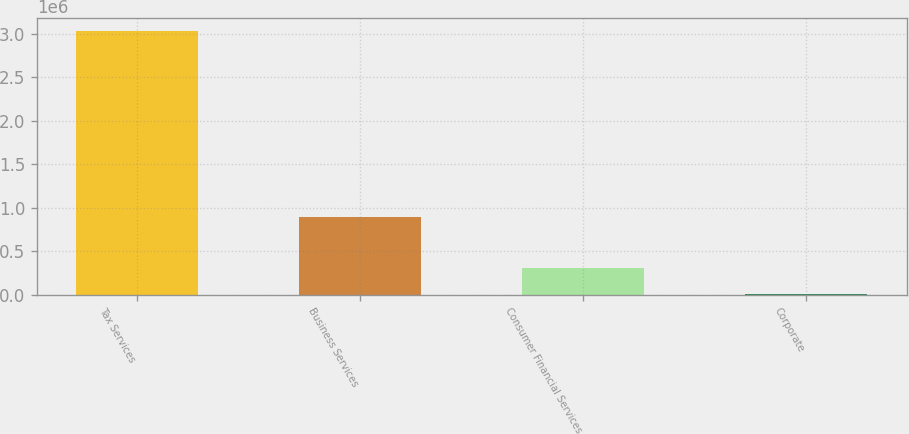<chart> <loc_0><loc_0><loc_500><loc_500><bar_chart><fcel>Tax Services<fcel>Business Services<fcel>Consumer Financial Services<fcel>Corporate<nl><fcel>3.03312e+06<fcel>897809<fcel>313072<fcel>10844<nl></chart> 